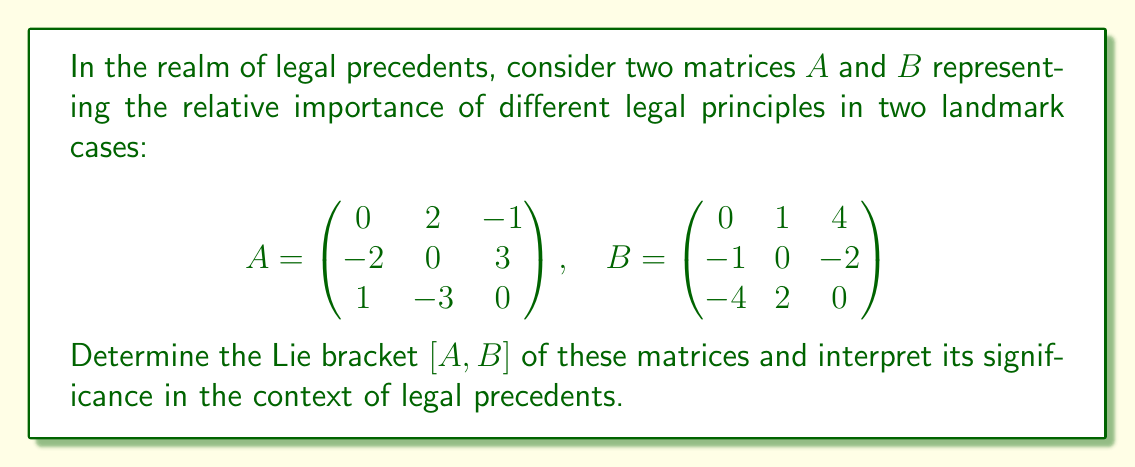Can you solve this math problem? To solve this problem, we need to follow these steps:

1) The Lie bracket of two matrices $A$ and $B$ is defined as $[A,B] = AB - BA$.

2) First, let's calculate $AB$:

   $$AB = \begin{pmatrix}
   0 & 2 & -1 \\
   -2 & 0 & 3 \\
   1 & -3 & 0
   \end{pmatrix} \begin{pmatrix}
   0 & 1 & 4 \\
   -1 & 0 & -2 \\
   -4 & 2 & 0
   \end{pmatrix} = \begin{pmatrix}
   2 & -2 & -8 \\
   -12 & 6 & 0 \\
   7 & -2 & -6
   \end{pmatrix}$$

3) Now, let's calculate $BA$:

   $$BA = \begin{pmatrix}
   0 & 1 & 4 \\
   -1 & 0 & -2 \\
   -4 & 2 & 0
   \end{pmatrix} \begin{pmatrix}
   0 & 2 & -1 \\
   -2 & 0 & 3 \\
   1 & -3 & 0
   \end{pmatrix} = \begin{pmatrix}
   2 & -10 & 0 \\
   -3 & -4 & 2 \\
   -4 & 0 & -10
   \end{pmatrix}$$

4) Now we can calculate $[A,B] = AB - BA$:

   $$[A,B] = \begin{pmatrix}
   2 & -2 & -8 \\
   -12 & 6 & 0 \\
   7 & -2 & -6
   \end{pmatrix} - \begin{pmatrix}
   2 & -10 & 0 \\
   -3 & -4 & 2 \\
   -4 & 0 & -10
   \end{pmatrix} = \begin{pmatrix}
   0 & 8 & -8 \\
   -9 & 10 & -2 \\
   11 & -2 & 4
   \end{pmatrix}$$

Interpretation: In the context of legal precedents, the Lie bracket $[A,B]$ represents the "commutator" of the two cases, highlighting how the order of consideration of these cases affects their combined impact. Non-zero elements in $[A,B]$ indicate areas where the order of precedent matters, potentially revealing conflicts or synergies in legal principles between the two cases.
Answer: The Lie bracket $[A,B]$ is:

$$[A,B] = \begin{pmatrix}
0 & 8 & -8 \\
-9 & 10 & -2 \\
11 & -2 & 4
\end{pmatrix}$$

This result indicates significant interactions between the legal principles represented in matrices $A$ and $B$, with the order of consideration playing a crucial role in their combined effect on legal precedent. 